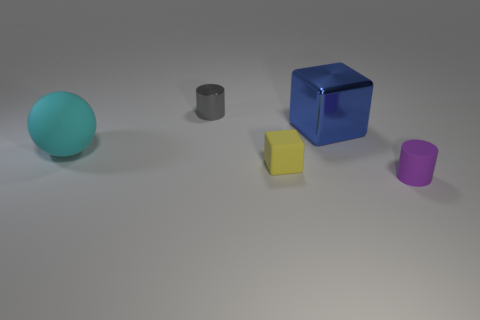What is the color of the large object right of the matte thing that is left of the tiny object that is behind the large blue object?
Offer a terse response. Blue. There is a tiny cylinder that is behind the tiny purple cylinder; is its color the same as the matte object that is behind the tiny yellow rubber block?
Your response must be concise. No. There is a small cylinder that is behind the small purple rubber cylinder; how many matte blocks are on the left side of it?
Offer a terse response. 0. Are there any red metallic balls?
Your answer should be very brief. No. How many other things are there of the same color as the large matte sphere?
Provide a short and direct response. 0. Is the number of large shiny things less than the number of small matte things?
Provide a succinct answer. Yes. There is a rubber object that is to the left of the cylinder that is behind the purple matte object; what is its shape?
Your response must be concise. Sphere. There is a large shiny cube; are there any metal objects left of it?
Offer a very short reply. Yes. What color is the metallic cylinder that is the same size as the yellow matte object?
Your response must be concise. Gray. What number of large spheres have the same material as the purple cylinder?
Provide a succinct answer. 1. 